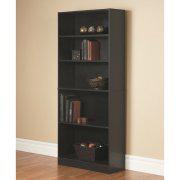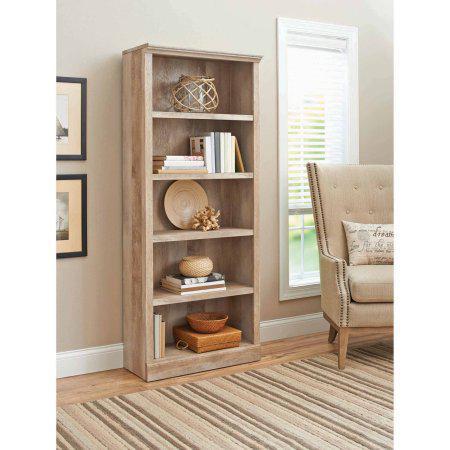The first image is the image on the left, the second image is the image on the right. Considering the images on both sides, is "One of the bookshelves is white." valid? Answer yes or no. No. 